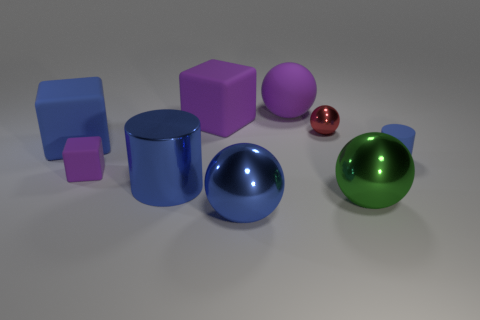There is a blue cube; are there any tiny purple things in front of it?
Your answer should be very brief. Yes. There is a metal sphere behind the large shiny ball that is to the right of the purple rubber sphere; are there any tiny things that are in front of it?
Your answer should be compact. Yes. Do the small rubber thing on the right side of the large blue shiny ball and the red metal object have the same shape?
Your answer should be compact. No. What color is the big sphere that is made of the same material as the small purple object?
Keep it short and to the point. Purple. How many big blue things are the same material as the tiny block?
Keep it short and to the point. 1. The cylinder that is right of the large shiny ball that is behind the big blue shiny thing that is on the right side of the metallic cylinder is what color?
Keep it short and to the point. Blue. Is the size of the blue sphere the same as the blue matte cylinder?
Offer a terse response. No. Are there any other things that are the same shape as the red shiny object?
Make the answer very short. Yes. What number of objects are either purple matte things that are in front of the big rubber sphere or tiny rubber blocks?
Ensure brevity in your answer.  2. Does the tiny blue thing have the same shape as the tiny purple rubber object?
Make the answer very short. No. 